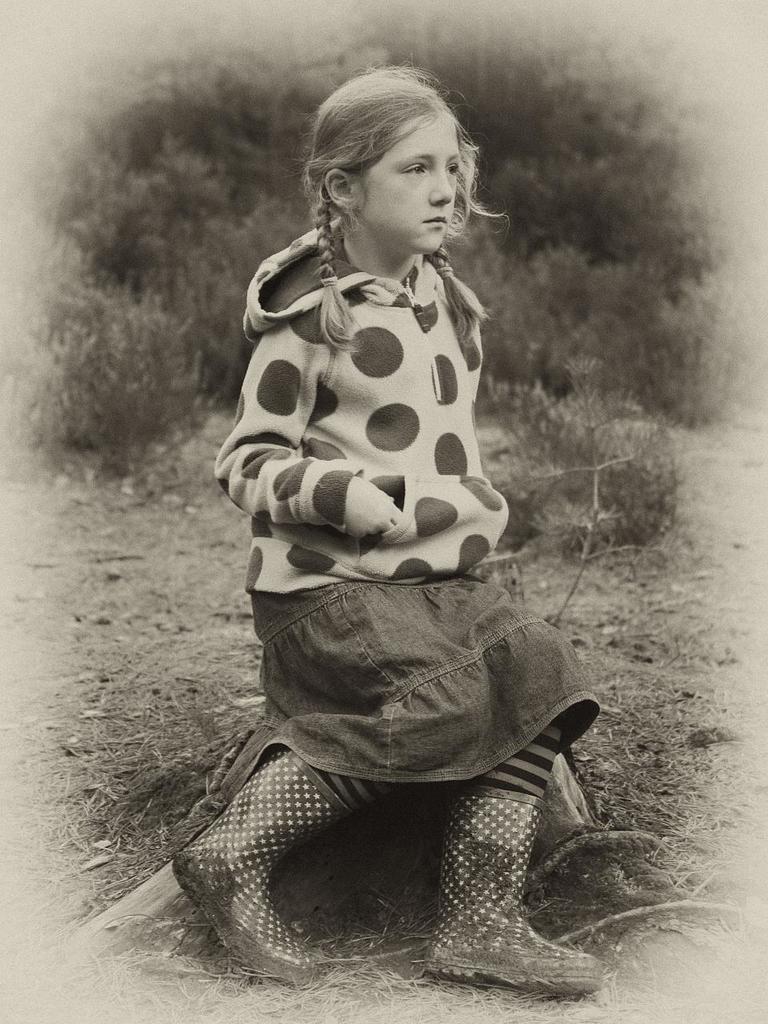Please provide a concise description of this image. In the picture we can see a black and white photograph of a girl sitting on the stone and behind her we can see some plants. 